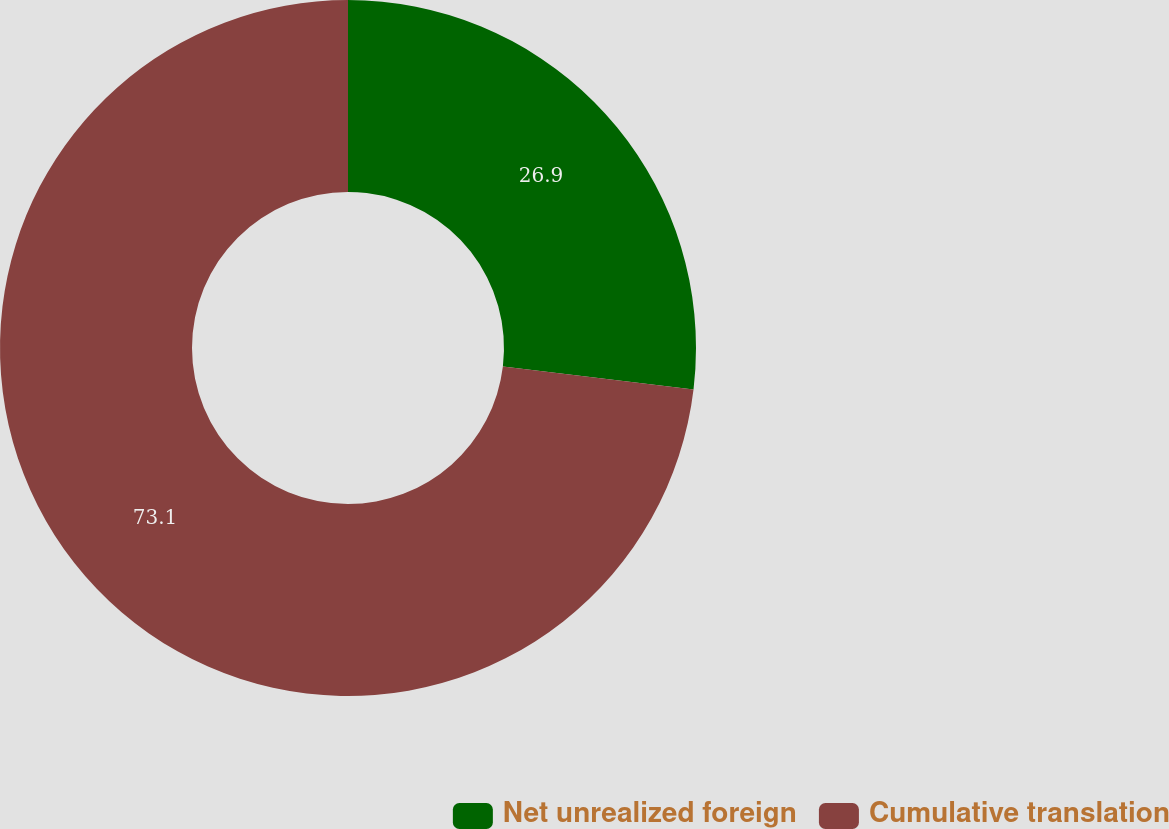Convert chart. <chart><loc_0><loc_0><loc_500><loc_500><pie_chart><fcel>Net unrealized foreign<fcel>Cumulative translation<nl><fcel>26.9%<fcel>73.1%<nl></chart> 